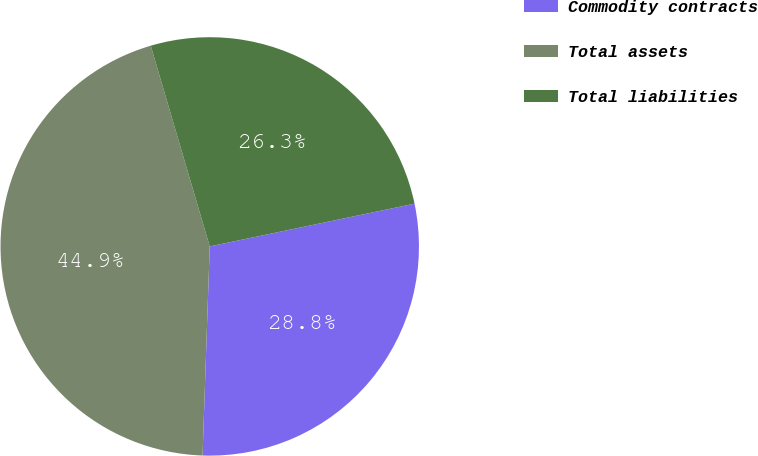<chart> <loc_0><loc_0><loc_500><loc_500><pie_chart><fcel>Commodity contracts<fcel>Total assets<fcel>Total liabilities<nl><fcel>28.82%<fcel>44.9%<fcel>26.27%<nl></chart> 